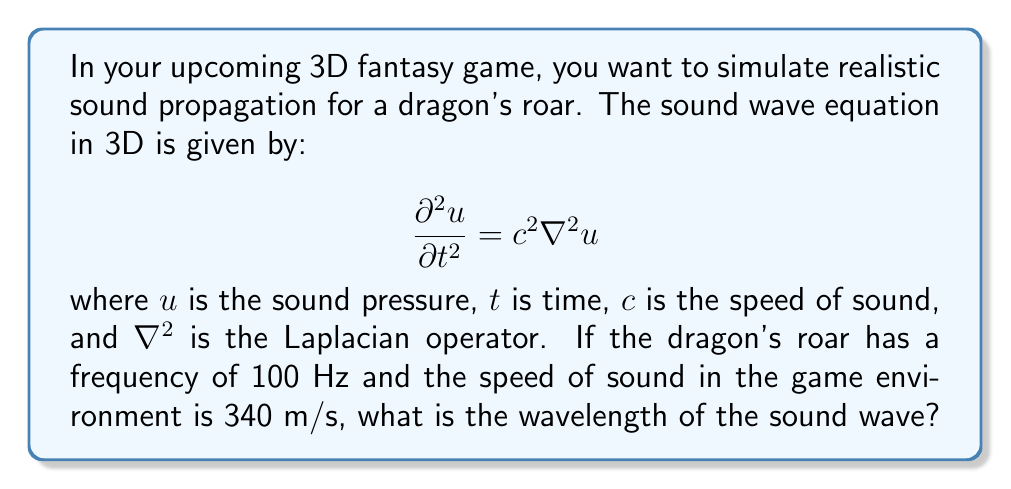Can you answer this question? To solve this problem, we'll use the wave equation and the relationship between frequency, wavelength, and speed of sound:

1) The general relationship between frequency ($f$), wavelength ($\lambda$), and speed of sound ($c$) is:

   $$c = f \lambda$$

2) We are given:
   - Frequency, $f = 100$ Hz
   - Speed of sound, $c = 340$ m/s

3) Rearranging the equation to solve for wavelength:

   $$\lambda = \frac{c}{f}$$

4) Substituting the known values:

   $$\lambda = \frac{340 \text{ m/s}}{100 \text{ Hz}}$$

5) Simplifying:

   $$\lambda = 3.4 \text{ m}$$

Therefore, the wavelength of the dragon's roar in the game environment is 3.4 meters.
Answer: 3.4 m 